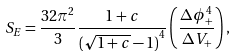<formula> <loc_0><loc_0><loc_500><loc_500>S _ { E } = \frac { 3 2 \pi ^ { 2 } } { 3 } \frac { 1 + c } { { ( \sqrt { 1 + c } - 1 ) } ^ { 4 } } \left ( \frac { \Delta \phi _ { + } ^ { 4 } } { \Delta V _ { + } } \right ) ,</formula> 